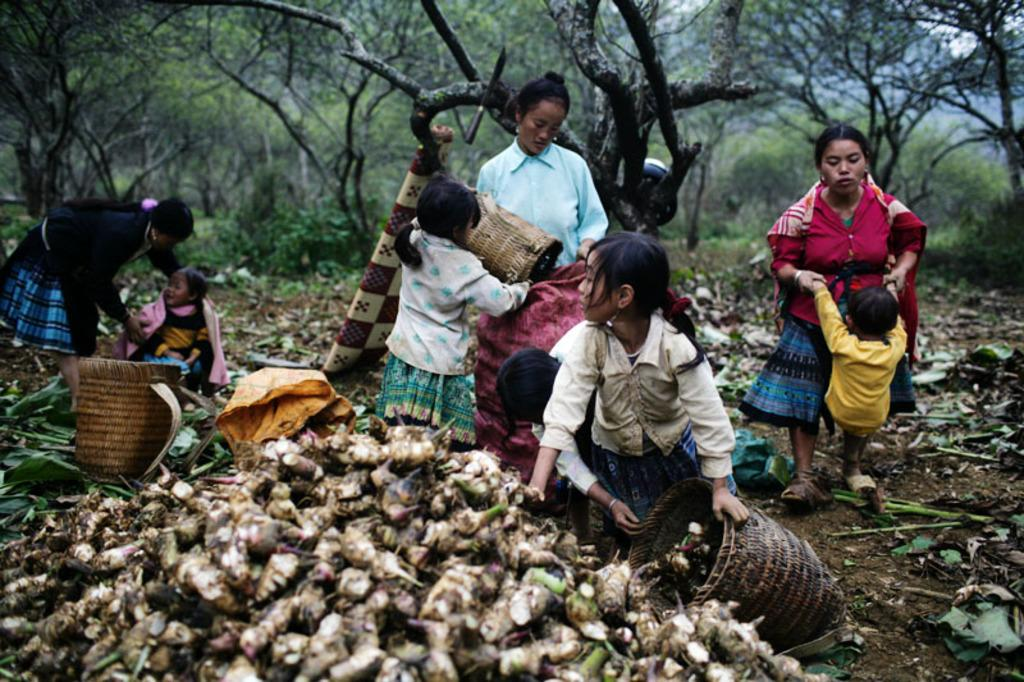How many people are in the image? There is a group of people in the image, but the exact number cannot be determined from the provided facts. What objects are visible in the image besides the people? There are baskets in the image. What might be inside the baskets? The baskets appear to contain sweet potatoes. What can be seen in the background of the image? There are trees in the background of the image. What type of oil is being used to cook the sweet potatoes in the image? There is no indication in the image that the sweet potatoes are being cooked, nor is there any mention of oil. 